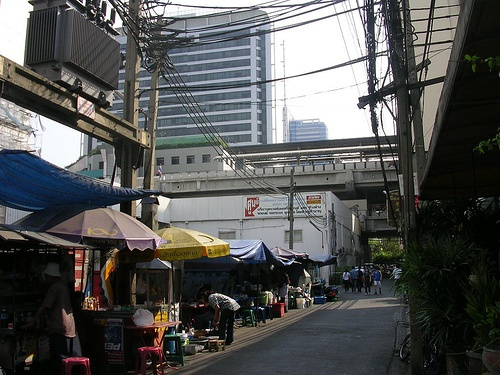Describe the objects in this image and their specific colors. I can see umbrella in pink, black, gray, and darkgray tones, people in pink, black, gray, brown, and maroon tones, umbrella in pink, tan, olive, beige, and maroon tones, people in pink, black, gray, darkgray, and lightgray tones, and chair in pink, black, maroon, brown, and gray tones in this image. 